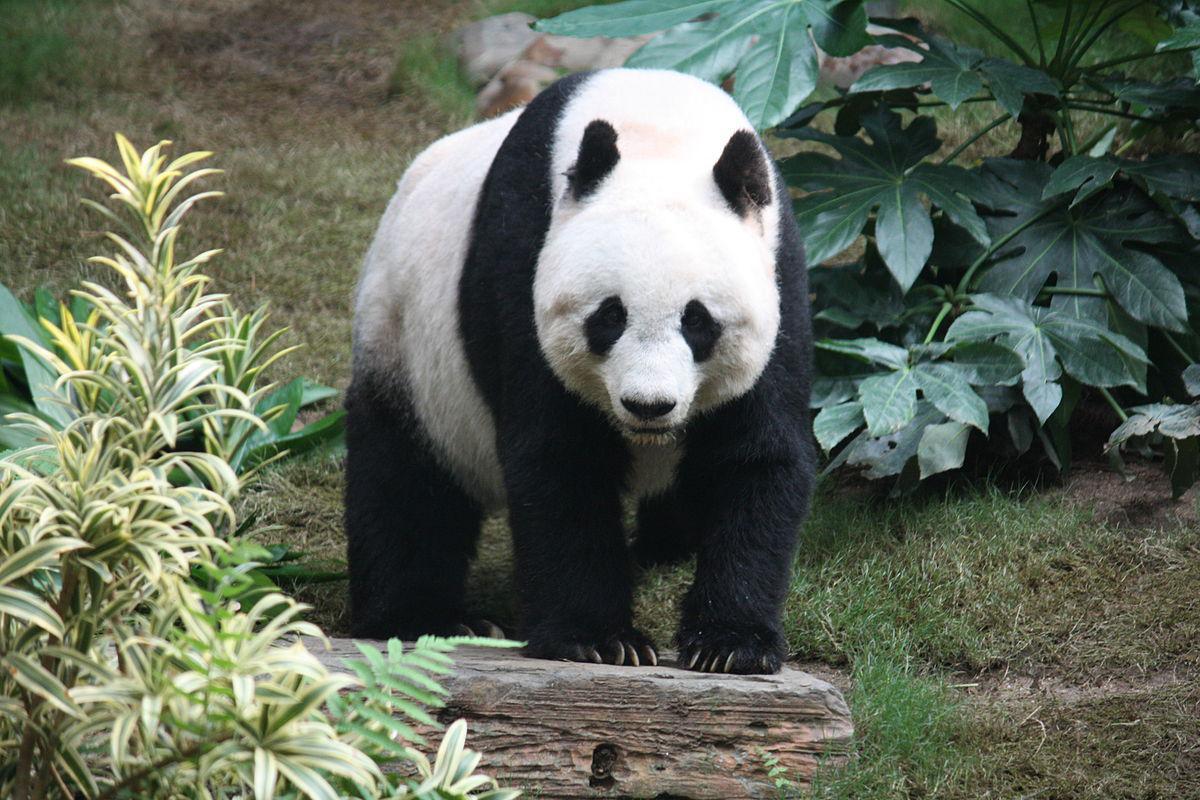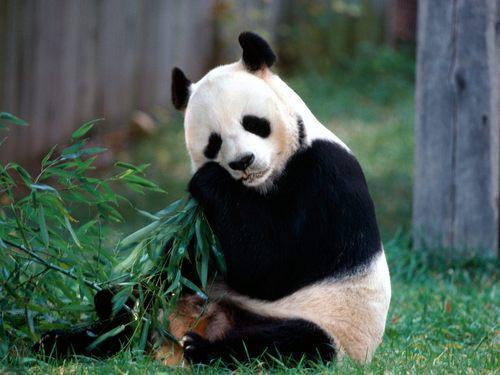The first image is the image on the left, the second image is the image on the right. Evaluate the accuracy of this statement regarding the images: "At least one panda is standing on all 4 legs.". Is it true? Answer yes or no. Yes. 